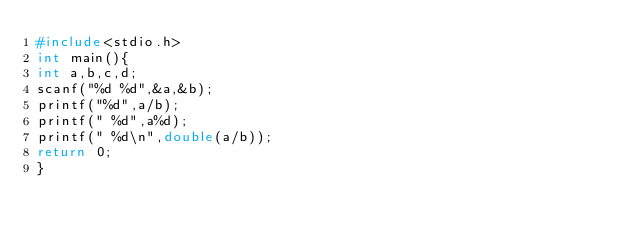<code> <loc_0><loc_0><loc_500><loc_500><_C_>#include<stdio.h>
int main(){
int a,b,c,d;
scanf("%d %d",&a,&b);
printf("%d",a/b);
printf(" %d",a%d);
printf(" %d\n",double(a/b));
return 0;
}</code> 